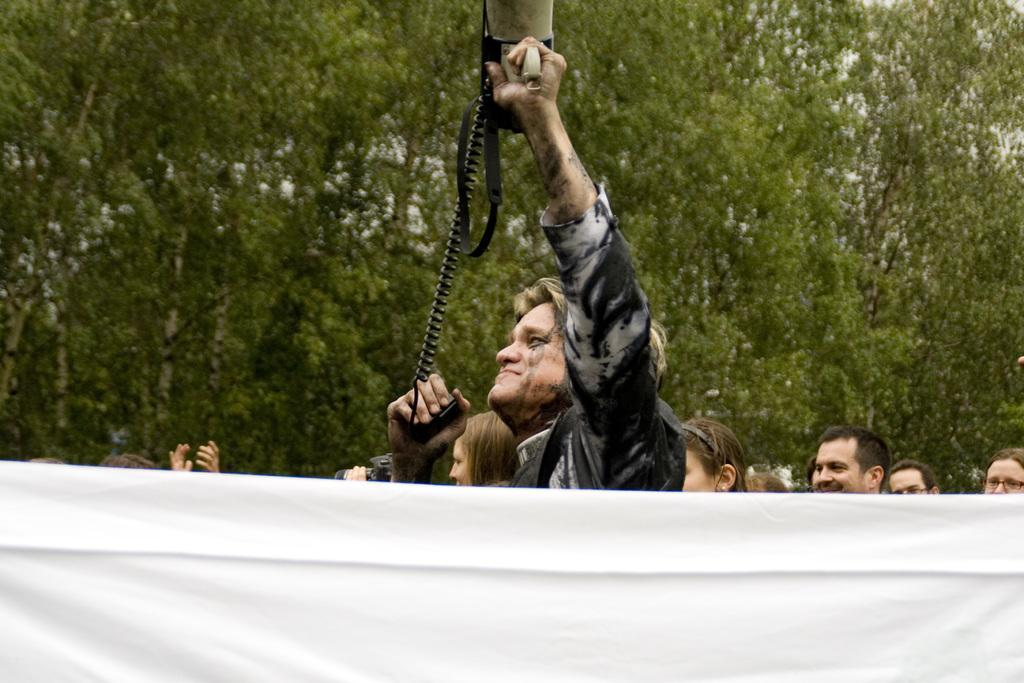What is the main subject of the image? The main subject of the image is a group of people. Can you describe the person in the middle of the image? The person in the middle of the image is holding a megaphone. What can be seen in the background of the image? There are trees in the background of the image. What type of rose can be seen growing on the person holding the megaphone? There is no rose present in the image, and the person holding the megaphone is not associated with any plant. What type of steel structure can be seen in the background of the image? There is no steel structure present in the image; the background only features trees. 